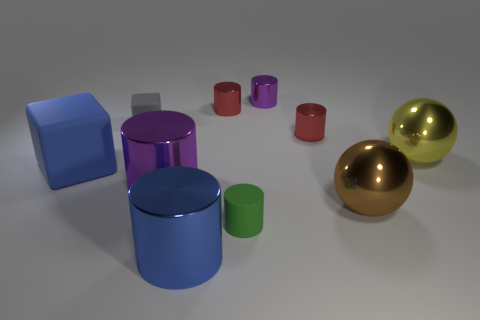Subtract all blue metal cylinders. How many cylinders are left? 5 Subtract all purple balls. How many red cylinders are left? 2 Subtract 2 cylinders. How many cylinders are left? 4 Subtract all red cylinders. How many cylinders are left? 4 Subtract all cubes. How many objects are left? 8 Subtract all green cylinders. Subtract all purple balls. How many cylinders are left? 5 Subtract all big gray cubes. Subtract all large cylinders. How many objects are left? 8 Add 1 blue matte things. How many blue matte things are left? 2 Add 1 brown balls. How many brown balls exist? 2 Subtract 0 yellow cubes. How many objects are left? 10 